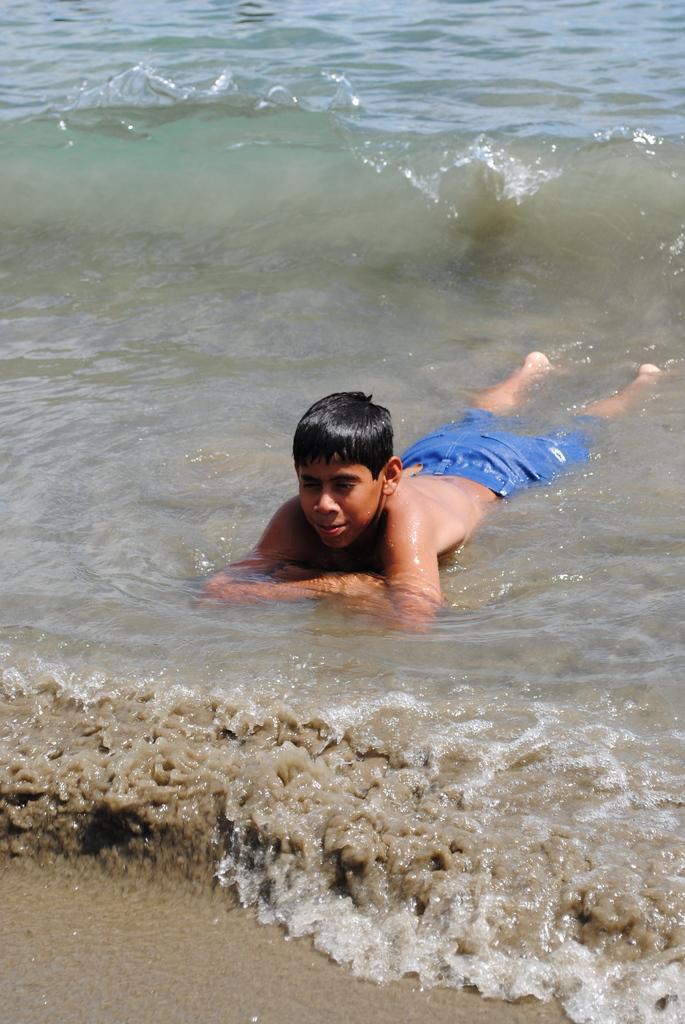Please provide a concise description of this image. This is a picture of a boy in the water. 